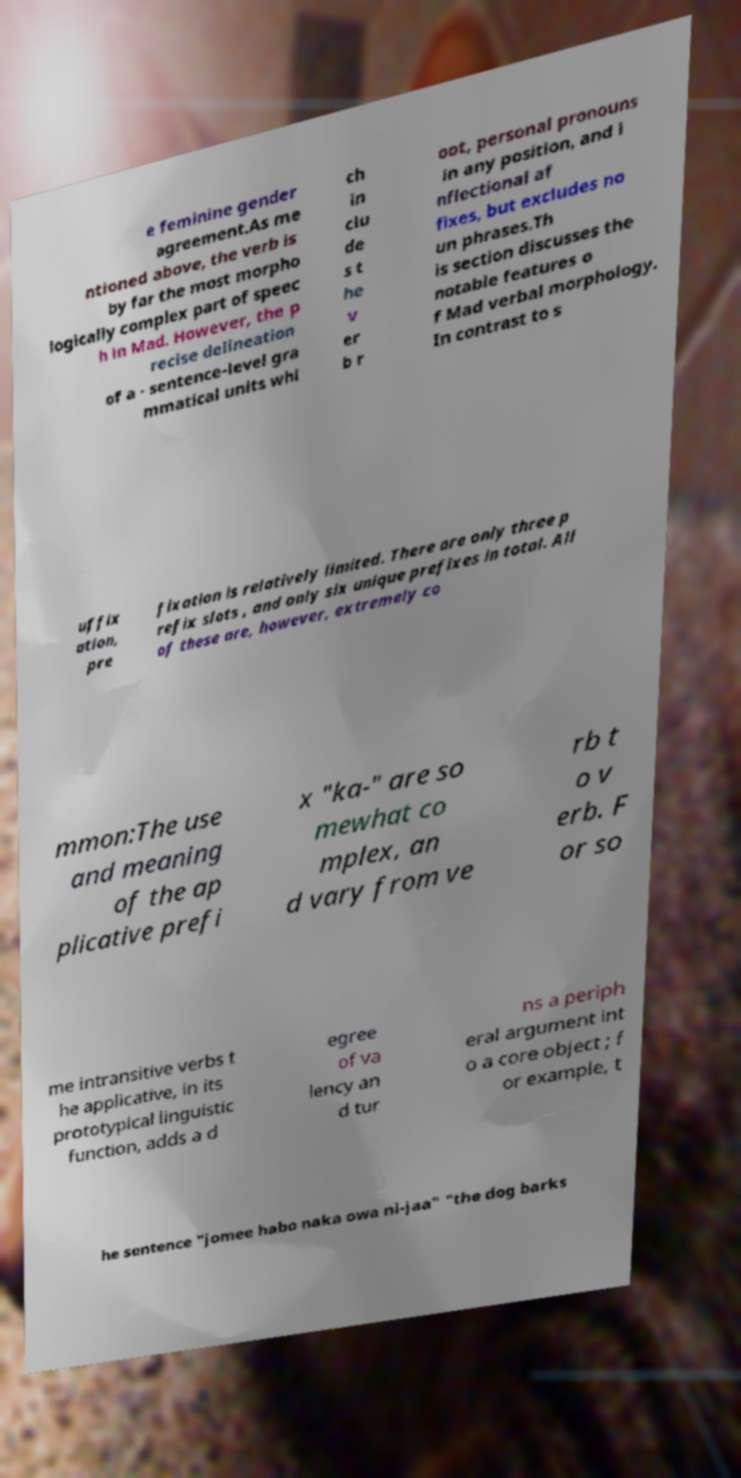Can you accurately transcribe the text from the provided image for me? e feminine gender agreement.As me ntioned above, the verb is by far the most morpho logically complex part of speec h in Mad. However, the p recise delineation of a - sentence-level gra mmatical units whi ch in clu de s t he v er b r oot, personal pronouns in any position, and i nflectional af fixes, but excludes no un phrases.Th is section discusses the notable features o f Mad verbal morphology. In contrast to s uffix ation, pre fixation is relatively limited. There are only three p refix slots , and only six unique prefixes in total. All of these are, however, extremely co mmon:The use and meaning of the ap plicative prefi x "ka-" are so mewhat co mplex, an d vary from ve rb t o v erb. F or so me intransitive verbs t he applicative, in its prototypical linguistic function, adds a d egree of va lency an d tur ns a periph eral argument int o a core object ; f or example, t he sentence "jomee habo naka owa ni-jaa" "the dog barks 